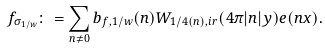<formula> <loc_0><loc_0><loc_500><loc_500>f _ { \sigma _ { 1 / w } } \colon = \sum _ { n \neq 0 } b _ { f , 1 / w } ( n ) W _ { 1 / 4 ( n ) , i r } ( 4 \pi | n | y ) e ( n x ) .</formula> 